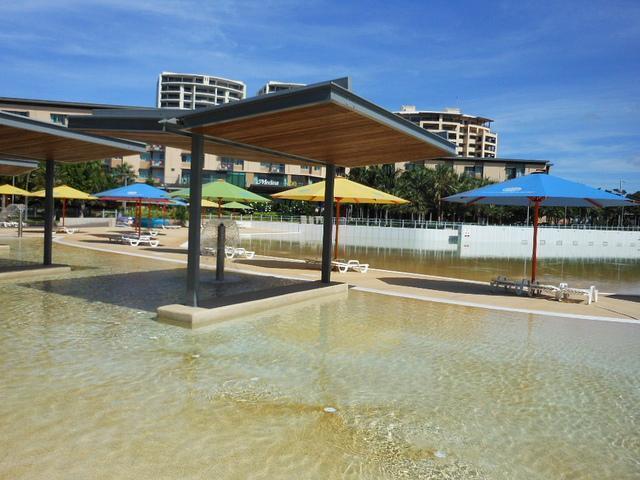This pool is mainly for what swimmers?
Make your selection from the four choices given to correctly answer the question.
Options: Kids, experienced swimmers, pregnant women, elderly people. Kids. 